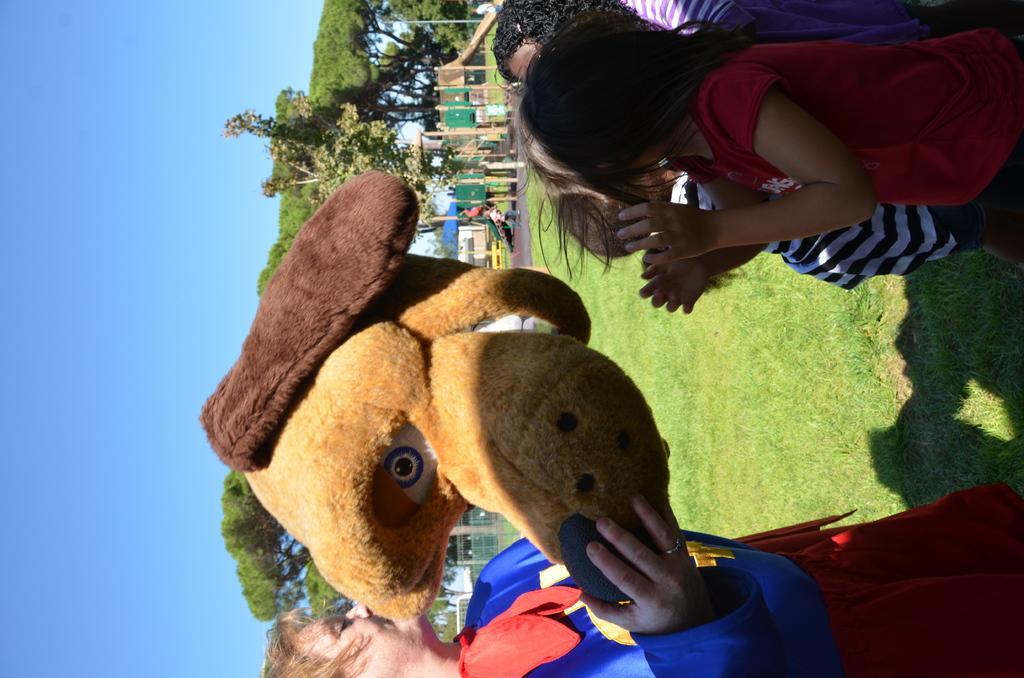Can you describe this image briefly? This picture is taken from outside of the city. In this image, on the left side, we can see a person holding a mask in hand. On the right side, we can see few kids. In the background, we can see few trees, plants, houses. At the top, we can see a sky, at the bottom, we can see a grass. 